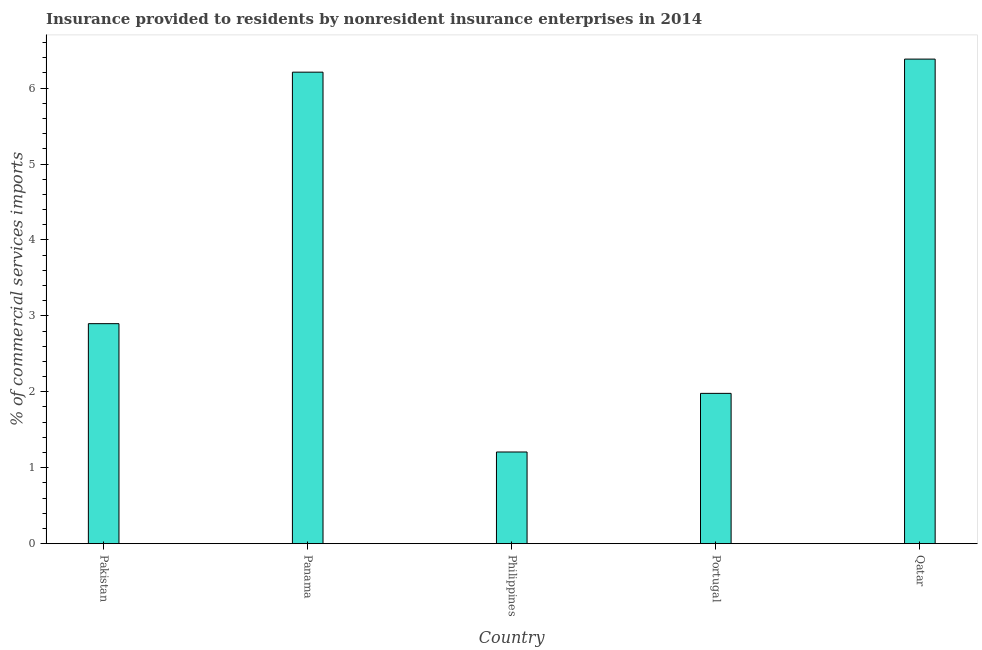Does the graph contain any zero values?
Keep it short and to the point. No. What is the title of the graph?
Your response must be concise. Insurance provided to residents by nonresident insurance enterprises in 2014. What is the label or title of the X-axis?
Ensure brevity in your answer.  Country. What is the label or title of the Y-axis?
Ensure brevity in your answer.  % of commercial services imports. What is the insurance provided by non-residents in Panama?
Ensure brevity in your answer.  6.21. Across all countries, what is the maximum insurance provided by non-residents?
Give a very brief answer. 6.38. Across all countries, what is the minimum insurance provided by non-residents?
Offer a very short reply. 1.21. In which country was the insurance provided by non-residents maximum?
Offer a terse response. Qatar. In which country was the insurance provided by non-residents minimum?
Ensure brevity in your answer.  Philippines. What is the sum of the insurance provided by non-residents?
Keep it short and to the point. 18.67. What is the difference between the insurance provided by non-residents in Pakistan and Qatar?
Offer a terse response. -3.48. What is the average insurance provided by non-residents per country?
Offer a terse response. 3.73. What is the median insurance provided by non-residents?
Offer a very short reply. 2.9. What is the ratio of the insurance provided by non-residents in Pakistan to that in Panama?
Your response must be concise. 0.47. Is the insurance provided by non-residents in Panama less than that in Qatar?
Provide a succinct answer. Yes. Is the difference between the insurance provided by non-residents in Panama and Portugal greater than the difference between any two countries?
Make the answer very short. No. What is the difference between the highest and the second highest insurance provided by non-residents?
Keep it short and to the point. 0.17. Is the sum of the insurance provided by non-residents in Pakistan and Philippines greater than the maximum insurance provided by non-residents across all countries?
Make the answer very short. No. What is the difference between the highest and the lowest insurance provided by non-residents?
Give a very brief answer. 5.17. Are all the bars in the graph horizontal?
Give a very brief answer. No. How many countries are there in the graph?
Your answer should be very brief. 5. Are the values on the major ticks of Y-axis written in scientific E-notation?
Your answer should be compact. No. What is the % of commercial services imports of Pakistan?
Offer a terse response. 2.9. What is the % of commercial services imports of Panama?
Keep it short and to the point. 6.21. What is the % of commercial services imports of Philippines?
Keep it short and to the point. 1.21. What is the % of commercial services imports of Portugal?
Make the answer very short. 1.98. What is the % of commercial services imports in Qatar?
Ensure brevity in your answer.  6.38. What is the difference between the % of commercial services imports in Pakistan and Panama?
Provide a succinct answer. -3.31. What is the difference between the % of commercial services imports in Pakistan and Philippines?
Your answer should be very brief. 1.69. What is the difference between the % of commercial services imports in Pakistan and Portugal?
Give a very brief answer. 0.92. What is the difference between the % of commercial services imports in Pakistan and Qatar?
Your answer should be very brief. -3.48. What is the difference between the % of commercial services imports in Panama and Philippines?
Offer a terse response. 5. What is the difference between the % of commercial services imports in Panama and Portugal?
Your answer should be compact. 4.23. What is the difference between the % of commercial services imports in Panama and Qatar?
Provide a succinct answer. -0.17. What is the difference between the % of commercial services imports in Philippines and Portugal?
Offer a very short reply. -0.77. What is the difference between the % of commercial services imports in Philippines and Qatar?
Make the answer very short. -5.17. What is the difference between the % of commercial services imports in Portugal and Qatar?
Provide a succinct answer. -4.4. What is the ratio of the % of commercial services imports in Pakistan to that in Panama?
Your answer should be very brief. 0.47. What is the ratio of the % of commercial services imports in Pakistan to that in Portugal?
Your answer should be very brief. 1.46. What is the ratio of the % of commercial services imports in Pakistan to that in Qatar?
Offer a very short reply. 0.45. What is the ratio of the % of commercial services imports in Panama to that in Philippines?
Ensure brevity in your answer.  5.14. What is the ratio of the % of commercial services imports in Panama to that in Portugal?
Give a very brief answer. 3.14. What is the ratio of the % of commercial services imports in Panama to that in Qatar?
Make the answer very short. 0.97. What is the ratio of the % of commercial services imports in Philippines to that in Portugal?
Your answer should be very brief. 0.61. What is the ratio of the % of commercial services imports in Philippines to that in Qatar?
Your response must be concise. 0.19. What is the ratio of the % of commercial services imports in Portugal to that in Qatar?
Keep it short and to the point. 0.31. 